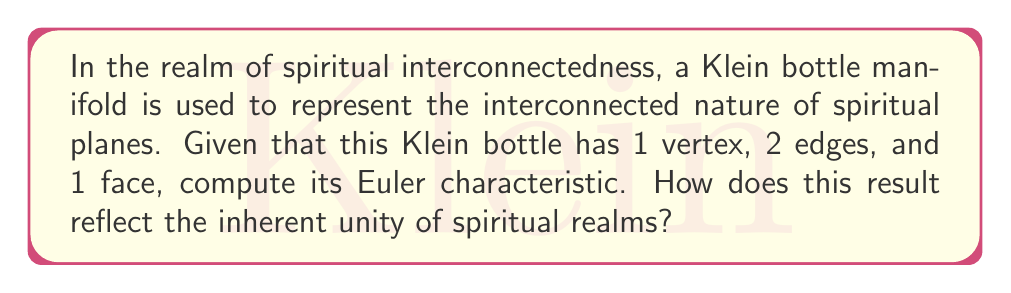Solve this math problem. To compute the Euler characteristic of the Klein bottle manifold representing interconnected spiritual realms, we'll follow these steps:

1. Recall the formula for Euler characteristic:
   $$\chi = V - E + F$$
   where $\chi$ is the Euler characteristic, $V$ is the number of vertices, $E$ is the number of edges, and $F$ is the number of faces.

2. Given information:
   - Vertices (V) = 1
   - Edges (E) = 2
   - Faces (F) = 1

3. Substitute these values into the formula:
   $$\chi = 1 - 2 + 1$$

4. Simplify:
   $$\chi = 0$$

The Euler characteristic of this Klein bottle manifold is 0.

Interpretation in the context of spiritual interconnectedness:

The Euler characteristic of 0 for this Klein bottle manifold is significant in representing the interconnectedness of spiritual realms. In topology, a Klein bottle is a non-orientable surface with no boundary, which can be seen as a metaphor for the seamless connection between different spiritual planes.

The fact that the Euler characteristic is 0 suggests a perfect balance or harmony in the structure. In spiritual terms, this could be interpreted as:

1. Unity: The zero value represents the undivided nature of spiritual realms, where distinctions between "separate" realms dissolve into a unified whole.

2. Cyclical nature: The Klein bottle's structure and the Euler characteristic of 0 can symbolize the cyclical nature of spiritual existence, with no true beginning or end.

3. Balance: The result of 0 can be seen as a balance between positive and negative aspects, reflecting the equilibrium often sought in spiritual practices.

4. Transcendence: The non-orientability of the Klein bottle, coupled with the Euler characteristic of 0, might represent the transcendent nature of spiritual realms beyond conventional dualistic thinking.

This mathematical result thus reinforces the concept of inherent unity and interconnectedness in spiritual philosophies, providing a concrete analogy for abstract spiritual concepts.
Answer: The Euler characteristic of the Klein bottle manifold is 0. 